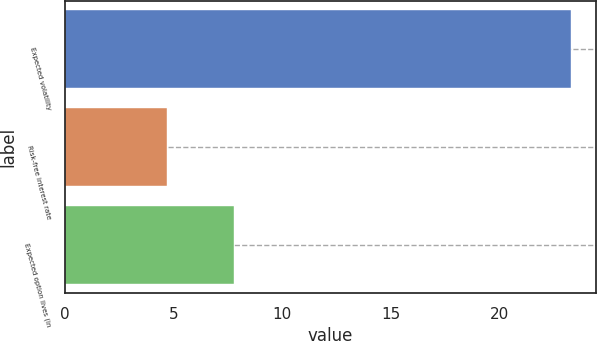<chart> <loc_0><loc_0><loc_500><loc_500><bar_chart><fcel>Expected volatility<fcel>Risk-free interest rate<fcel>Expected option lives (in<nl><fcel>23.3<fcel>4.69<fcel>7.8<nl></chart> 